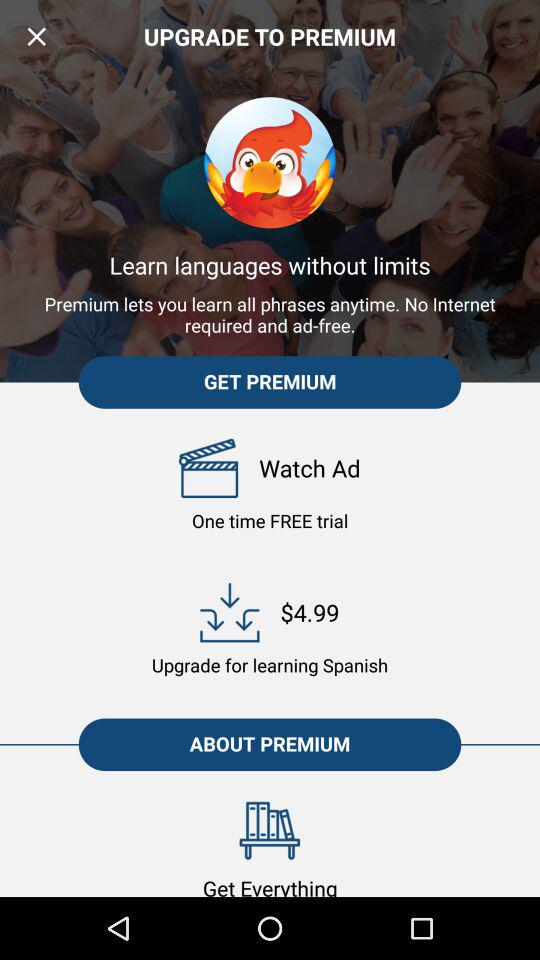How much more does it cost to upgrade to premium for Spanish than to watch a free ad?
Answer the question using a single word or phrase. $4.99 